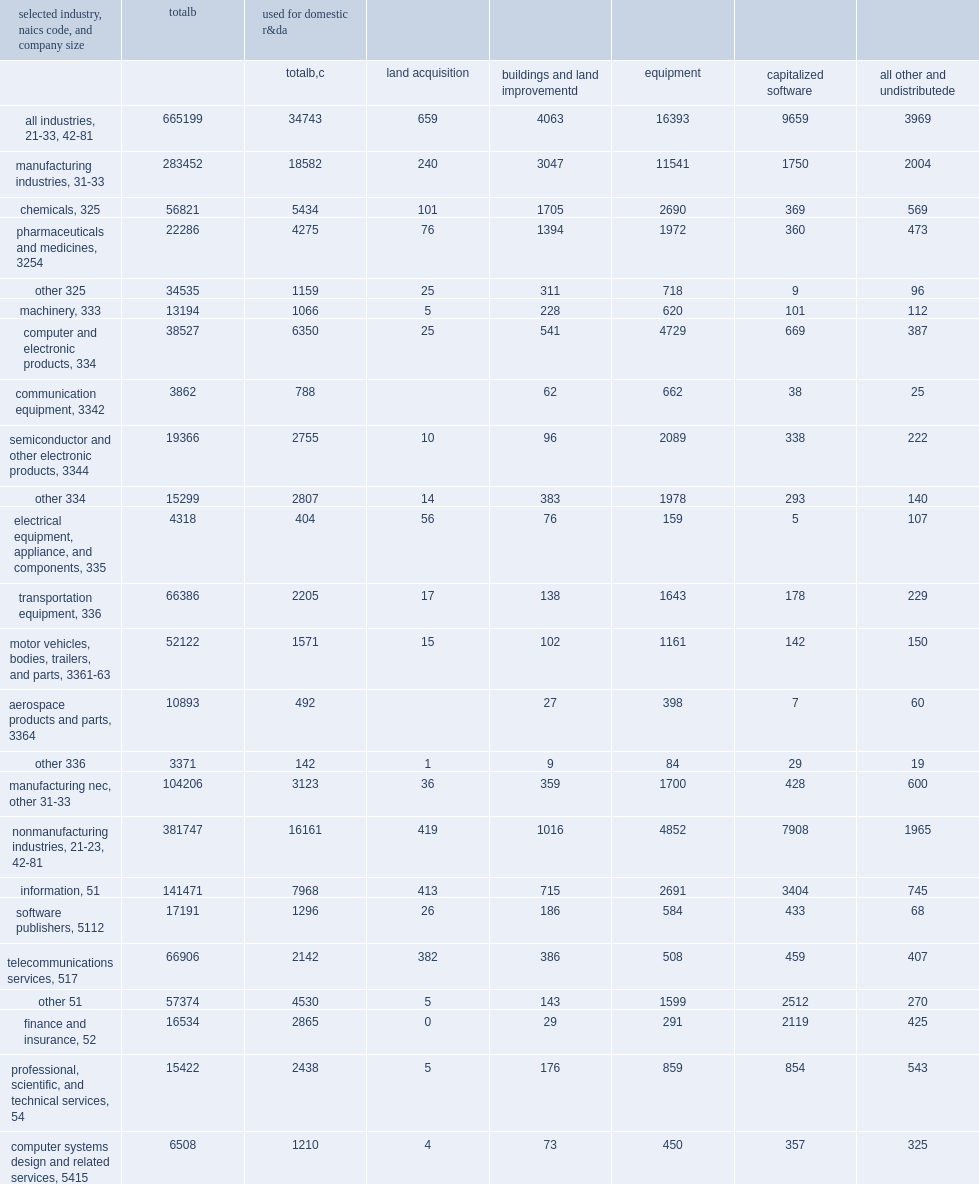How many million dollars did companies that performed or funded r&d in the united states in 2018 spend on assets with expected useful lives of more than 1 year? 665199.0. How many million dollars were spent on land acquisitions, buildings and land improvements, equipment, software, and other assets used for r&d? 34743.0. How many million dollars were spent on manufacturing industries used for r&d? 18582.0. How many million dollars were spent on non-manufacturing industries used for r&d? 16161.0. 